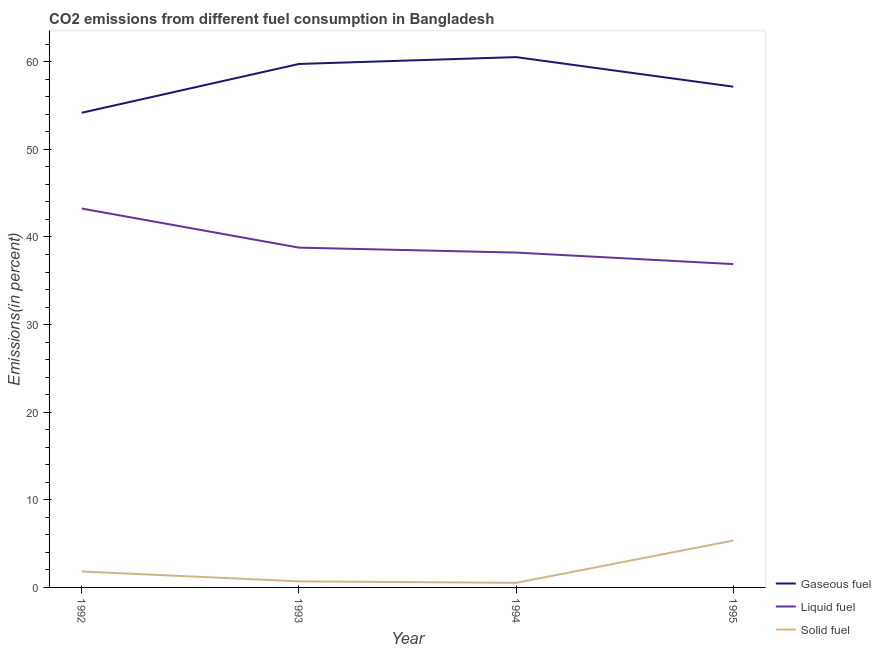What is the percentage of solid fuel emission in 1994?
Provide a short and direct response. 0.52. Across all years, what is the maximum percentage of gaseous fuel emission?
Keep it short and to the point. 60.53. Across all years, what is the minimum percentage of gaseous fuel emission?
Give a very brief answer. 54.17. In which year was the percentage of solid fuel emission minimum?
Ensure brevity in your answer.  1994. What is the total percentage of gaseous fuel emission in the graph?
Give a very brief answer. 231.59. What is the difference between the percentage of solid fuel emission in 1993 and that in 1995?
Provide a short and direct response. -4.66. What is the difference between the percentage of gaseous fuel emission in 1995 and the percentage of solid fuel emission in 1993?
Keep it short and to the point. 56.46. What is the average percentage of gaseous fuel emission per year?
Give a very brief answer. 57.9. In the year 1994, what is the difference between the percentage of solid fuel emission and percentage of gaseous fuel emission?
Provide a short and direct response. -60. What is the ratio of the percentage of liquid fuel emission in 1992 to that in 1993?
Ensure brevity in your answer.  1.12. Is the difference between the percentage of solid fuel emission in 1993 and 1994 greater than the difference between the percentage of liquid fuel emission in 1993 and 1994?
Your response must be concise. No. What is the difference between the highest and the second highest percentage of liquid fuel emission?
Offer a terse response. 4.46. What is the difference between the highest and the lowest percentage of solid fuel emission?
Offer a terse response. 4.83. Is the sum of the percentage of liquid fuel emission in 1994 and 1995 greater than the maximum percentage of gaseous fuel emission across all years?
Your answer should be compact. Yes. Is it the case that in every year, the sum of the percentage of gaseous fuel emission and percentage of liquid fuel emission is greater than the percentage of solid fuel emission?
Ensure brevity in your answer.  Yes. Is the percentage of liquid fuel emission strictly greater than the percentage of gaseous fuel emission over the years?
Provide a succinct answer. No. Is the percentage of solid fuel emission strictly less than the percentage of liquid fuel emission over the years?
Keep it short and to the point. Yes. Are the values on the major ticks of Y-axis written in scientific E-notation?
Give a very brief answer. No. Where does the legend appear in the graph?
Provide a short and direct response. Bottom right. How are the legend labels stacked?
Give a very brief answer. Vertical. What is the title of the graph?
Keep it short and to the point. CO2 emissions from different fuel consumption in Bangladesh. What is the label or title of the X-axis?
Make the answer very short. Year. What is the label or title of the Y-axis?
Keep it short and to the point. Emissions(in percent). What is the Emissions(in percent) of Gaseous fuel in 1992?
Your answer should be very brief. 54.17. What is the Emissions(in percent) of Liquid fuel in 1992?
Your answer should be compact. 43.24. What is the Emissions(in percent) in Solid fuel in 1992?
Give a very brief answer. 1.82. What is the Emissions(in percent) in Gaseous fuel in 1993?
Offer a very short reply. 59.74. What is the Emissions(in percent) of Liquid fuel in 1993?
Make the answer very short. 38.78. What is the Emissions(in percent) in Solid fuel in 1993?
Keep it short and to the point. 0.7. What is the Emissions(in percent) of Gaseous fuel in 1994?
Give a very brief answer. 60.53. What is the Emissions(in percent) in Liquid fuel in 1994?
Ensure brevity in your answer.  38.22. What is the Emissions(in percent) of Solid fuel in 1994?
Give a very brief answer. 0.52. What is the Emissions(in percent) in Gaseous fuel in 1995?
Your response must be concise. 57.15. What is the Emissions(in percent) in Liquid fuel in 1995?
Offer a terse response. 36.9. What is the Emissions(in percent) of Solid fuel in 1995?
Provide a short and direct response. 5.35. Across all years, what is the maximum Emissions(in percent) of Gaseous fuel?
Offer a terse response. 60.53. Across all years, what is the maximum Emissions(in percent) in Liquid fuel?
Make the answer very short. 43.24. Across all years, what is the maximum Emissions(in percent) of Solid fuel?
Your response must be concise. 5.35. Across all years, what is the minimum Emissions(in percent) of Gaseous fuel?
Make the answer very short. 54.17. Across all years, what is the minimum Emissions(in percent) in Liquid fuel?
Provide a succinct answer. 36.9. Across all years, what is the minimum Emissions(in percent) of Solid fuel?
Make the answer very short. 0.52. What is the total Emissions(in percent) of Gaseous fuel in the graph?
Keep it short and to the point. 231.59. What is the total Emissions(in percent) in Liquid fuel in the graph?
Ensure brevity in your answer.  157.15. What is the total Emissions(in percent) in Solid fuel in the graph?
Keep it short and to the point. 8.39. What is the difference between the Emissions(in percent) in Gaseous fuel in 1992 and that in 1993?
Provide a short and direct response. -5.57. What is the difference between the Emissions(in percent) in Liquid fuel in 1992 and that in 1993?
Make the answer very short. 4.46. What is the difference between the Emissions(in percent) in Solid fuel in 1992 and that in 1993?
Offer a very short reply. 1.12. What is the difference between the Emissions(in percent) of Gaseous fuel in 1992 and that in 1994?
Make the answer very short. -6.35. What is the difference between the Emissions(in percent) in Liquid fuel in 1992 and that in 1994?
Ensure brevity in your answer.  5.03. What is the difference between the Emissions(in percent) in Solid fuel in 1992 and that in 1994?
Provide a succinct answer. 1.3. What is the difference between the Emissions(in percent) of Gaseous fuel in 1992 and that in 1995?
Keep it short and to the point. -2.98. What is the difference between the Emissions(in percent) in Liquid fuel in 1992 and that in 1995?
Make the answer very short. 6.34. What is the difference between the Emissions(in percent) in Solid fuel in 1992 and that in 1995?
Offer a terse response. -3.53. What is the difference between the Emissions(in percent) of Gaseous fuel in 1993 and that in 1994?
Your answer should be very brief. -0.78. What is the difference between the Emissions(in percent) of Liquid fuel in 1993 and that in 1994?
Keep it short and to the point. 0.56. What is the difference between the Emissions(in percent) of Solid fuel in 1993 and that in 1994?
Ensure brevity in your answer.  0.17. What is the difference between the Emissions(in percent) in Gaseous fuel in 1993 and that in 1995?
Provide a succinct answer. 2.59. What is the difference between the Emissions(in percent) in Liquid fuel in 1993 and that in 1995?
Your answer should be compact. 1.88. What is the difference between the Emissions(in percent) of Solid fuel in 1993 and that in 1995?
Your response must be concise. -4.66. What is the difference between the Emissions(in percent) of Gaseous fuel in 1994 and that in 1995?
Your response must be concise. 3.37. What is the difference between the Emissions(in percent) in Liquid fuel in 1994 and that in 1995?
Make the answer very short. 1.32. What is the difference between the Emissions(in percent) in Solid fuel in 1994 and that in 1995?
Offer a very short reply. -4.83. What is the difference between the Emissions(in percent) of Gaseous fuel in 1992 and the Emissions(in percent) of Liquid fuel in 1993?
Provide a short and direct response. 15.39. What is the difference between the Emissions(in percent) in Gaseous fuel in 1992 and the Emissions(in percent) in Solid fuel in 1993?
Your response must be concise. 53.48. What is the difference between the Emissions(in percent) of Liquid fuel in 1992 and the Emissions(in percent) of Solid fuel in 1993?
Ensure brevity in your answer.  42.55. What is the difference between the Emissions(in percent) of Gaseous fuel in 1992 and the Emissions(in percent) of Liquid fuel in 1994?
Keep it short and to the point. 15.96. What is the difference between the Emissions(in percent) of Gaseous fuel in 1992 and the Emissions(in percent) of Solid fuel in 1994?
Ensure brevity in your answer.  53.65. What is the difference between the Emissions(in percent) in Liquid fuel in 1992 and the Emissions(in percent) in Solid fuel in 1994?
Ensure brevity in your answer.  42.72. What is the difference between the Emissions(in percent) in Gaseous fuel in 1992 and the Emissions(in percent) in Liquid fuel in 1995?
Give a very brief answer. 17.27. What is the difference between the Emissions(in percent) of Gaseous fuel in 1992 and the Emissions(in percent) of Solid fuel in 1995?
Your response must be concise. 48.82. What is the difference between the Emissions(in percent) of Liquid fuel in 1992 and the Emissions(in percent) of Solid fuel in 1995?
Your answer should be very brief. 37.89. What is the difference between the Emissions(in percent) in Gaseous fuel in 1993 and the Emissions(in percent) in Liquid fuel in 1994?
Provide a succinct answer. 21.53. What is the difference between the Emissions(in percent) in Gaseous fuel in 1993 and the Emissions(in percent) in Solid fuel in 1994?
Keep it short and to the point. 59.22. What is the difference between the Emissions(in percent) in Liquid fuel in 1993 and the Emissions(in percent) in Solid fuel in 1994?
Make the answer very short. 38.26. What is the difference between the Emissions(in percent) in Gaseous fuel in 1993 and the Emissions(in percent) in Liquid fuel in 1995?
Keep it short and to the point. 22.84. What is the difference between the Emissions(in percent) in Gaseous fuel in 1993 and the Emissions(in percent) in Solid fuel in 1995?
Ensure brevity in your answer.  54.39. What is the difference between the Emissions(in percent) of Liquid fuel in 1993 and the Emissions(in percent) of Solid fuel in 1995?
Give a very brief answer. 33.43. What is the difference between the Emissions(in percent) in Gaseous fuel in 1994 and the Emissions(in percent) in Liquid fuel in 1995?
Provide a short and direct response. 23.62. What is the difference between the Emissions(in percent) of Gaseous fuel in 1994 and the Emissions(in percent) of Solid fuel in 1995?
Your answer should be very brief. 55.17. What is the difference between the Emissions(in percent) of Liquid fuel in 1994 and the Emissions(in percent) of Solid fuel in 1995?
Your answer should be very brief. 32.87. What is the average Emissions(in percent) in Gaseous fuel per year?
Keep it short and to the point. 57.9. What is the average Emissions(in percent) in Liquid fuel per year?
Keep it short and to the point. 39.29. What is the average Emissions(in percent) of Solid fuel per year?
Provide a short and direct response. 2.1. In the year 1992, what is the difference between the Emissions(in percent) of Gaseous fuel and Emissions(in percent) of Liquid fuel?
Ensure brevity in your answer.  10.93. In the year 1992, what is the difference between the Emissions(in percent) of Gaseous fuel and Emissions(in percent) of Solid fuel?
Your answer should be very brief. 52.36. In the year 1992, what is the difference between the Emissions(in percent) of Liquid fuel and Emissions(in percent) of Solid fuel?
Your response must be concise. 41.43. In the year 1993, what is the difference between the Emissions(in percent) of Gaseous fuel and Emissions(in percent) of Liquid fuel?
Make the answer very short. 20.96. In the year 1993, what is the difference between the Emissions(in percent) in Gaseous fuel and Emissions(in percent) in Solid fuel?
Provide a succinct answer. 59.05. In the year 1993, what is the difference between the Emissions(in percent) in Liquid fuel and Emissions(in percent) in Solid fuel?
Make the answer very short. 38.09. In the year 1994, what is the difference between the Emissions(in percent) in Gaseous fuel and Emissions(in percent) in Liquid fuel?
Provide a succinct answer. 22.31. In the year 1994, what is the difference between the Emissions(in percent) in Gaseous fuel and Emissions(in percent) in Solid fuel?
Your response must be concise. 60. In the year 1994, what is the difference between the Emissions(in percent) in Liquid fuel and Emissions(in percent) in Solid fuel?
Offer a very short reply. 37.7. In the year 1995, what is the difference between the Emissions(in percent) in Gaseous fuel and Emissions(in percent) in Liquid fuel?
Provide a short and direct response. 20.25. In the year 1995, what is the difference between the Emissions(in percent) in Gaseous fuel and Emissions(in percent) in Solid fuel?
Offer a very short reply. 51.8. In the year 1995, what is the difference between the Emissions(in percent) in Liquid fuel and Emissions(in percent) in Solid fuel?
Provide a short and direct response. 31.55. What is the ratio of the Emissions(in percent) of Gaseous fuel in 1992 to that in 1993?
Provide a succinct answer. 0.91. What is the ratio of the Emissions(in percent) of Liquid fuel in 1992 to that in 1993?
Your response must be concise. 1.11. What is the ratio of the Emissions(in percent) in Solid fuel in 1992 to that in 1993?
Offer a very short reply. 2.62. What is the ratio of the Emissions(in percent) of Gaseous fuel in 1992 to that in 1994?
Offer a very short reply. 0.9. What is the ratio of the Emissions(in percent) in Liquid fuel in 1992 to that in 1994?
Ensure brevity in your answer.  1.13. What is the ratio of the Emissions(in percent) of Solid fuel in 1992 to that in 1994?
Ensure brevity in your answer.  3.48. What is the ratio of the Emissions(in percent) in Gaseous fuel in 1992 to that in 1995?
Give a very brief answer. 0.95. What is the ratio of the Emissions(in percent) of Liquid fuel in 1992 to that in 1995?
Make the answer very short. 1.17. What is the ratio of the Emissions(in percent) of Solid fuel in 1992 to that in 1995?
Offer a very short reply. 0.34. What is the ratio of the Emissions(in percent) in Gaseous fuel in 1993 to that in 1994?
Provide a short and direct response. 0.99. What is the ratio of the Emissions(in percent) of Liquid fuel in 1993 to that in 1994?
Offer a very short reply. 1.01. What is the ratio of the Emissions(in percent) in Solid fuel in 1993 to that in 1994?
Offer a terse response. 1.33. What is the ratio of the Emissions(in percent) in Gaseous fuel in 1993 to that in 1995?
Offer a terse response. 1.05. What is the ratio of the Emissions(in percent) in Liquid fuel in 1993 to that in 1995?
Your response must be concise. 1.05. What is the ratio of the Emissions(in percent) in Solid fuel in 1993 to that in 1995?
Give a very brief answer. 0.13. What is the ratio of the Emissions(in percent) of Gaseous fuel in 1994 to that in 1995?
Your answer should be compact. 1.06. What is the ratio of the Emissions(in percent) of Liquid fuel in 1994 to that in 1995?
Your answer should be compact. 1.04. What is the ratio of the Emissions(in percent) in Solid fuel in 1994 to that in 1995?
Provide a succinct answer. 0.1. What is the difference between the highest and the second highest Emissions(in percent) in Gaseous fuel?
Provide a short and direct response. 0.78. What is the difference between the highest and the second highest Emissions(in percent) in Liquid fuel?
Your answer should be very brief. 4.46. What is the difference between the highest and the second highest Emissions(in percent) of Solid fuel?
Provide a short and direct response. 3.53. What is the difference between the highest and the lowest Emissions(in percent) in Gaseous fuel?
Keep it short and to the point. 6.35. What is the difference between the highest and the lowest Emissions(in percent) of Liquid fuel?
Your response must be concise. 6.34. What is the difference between the highest and the lowest Emissions(in percent) of Solid fuel?
Ensure brevity in your answer.  4.83. 